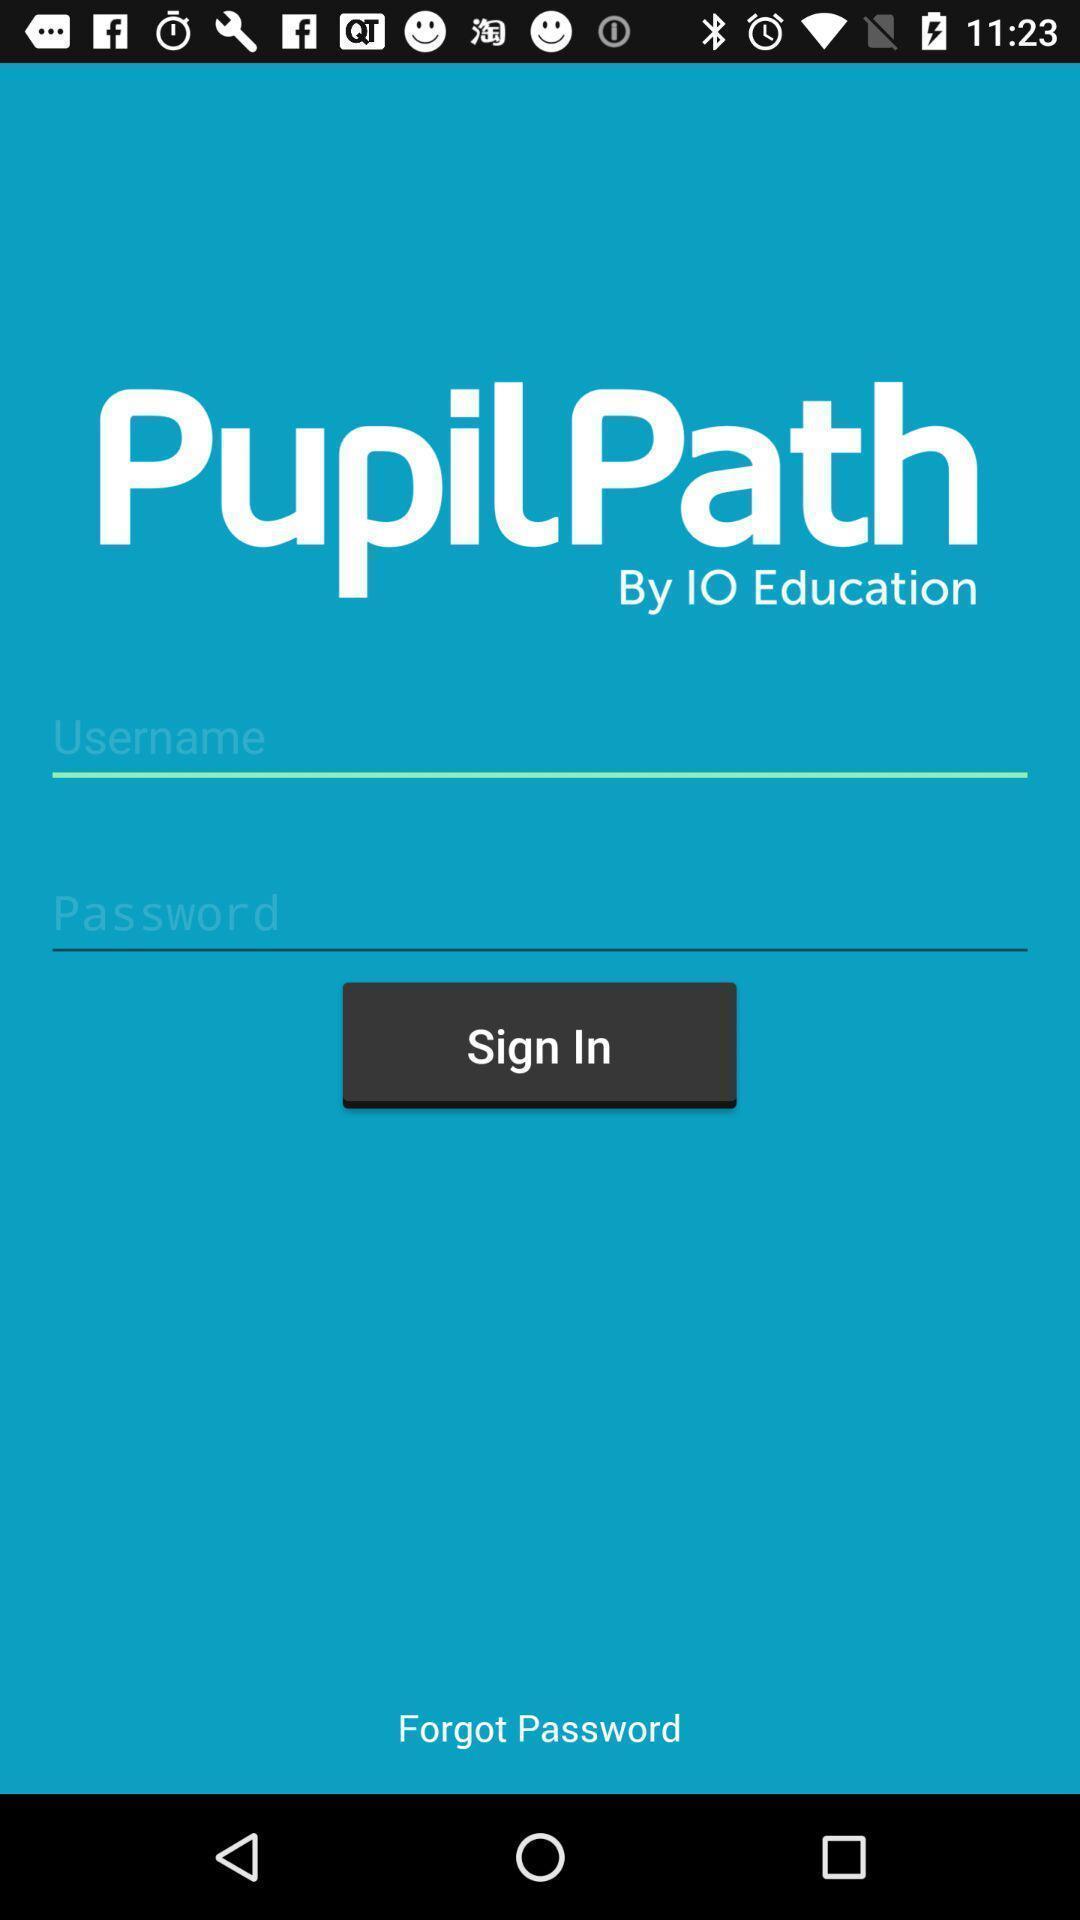Describe the key features of this screenshot. Welcome page. 